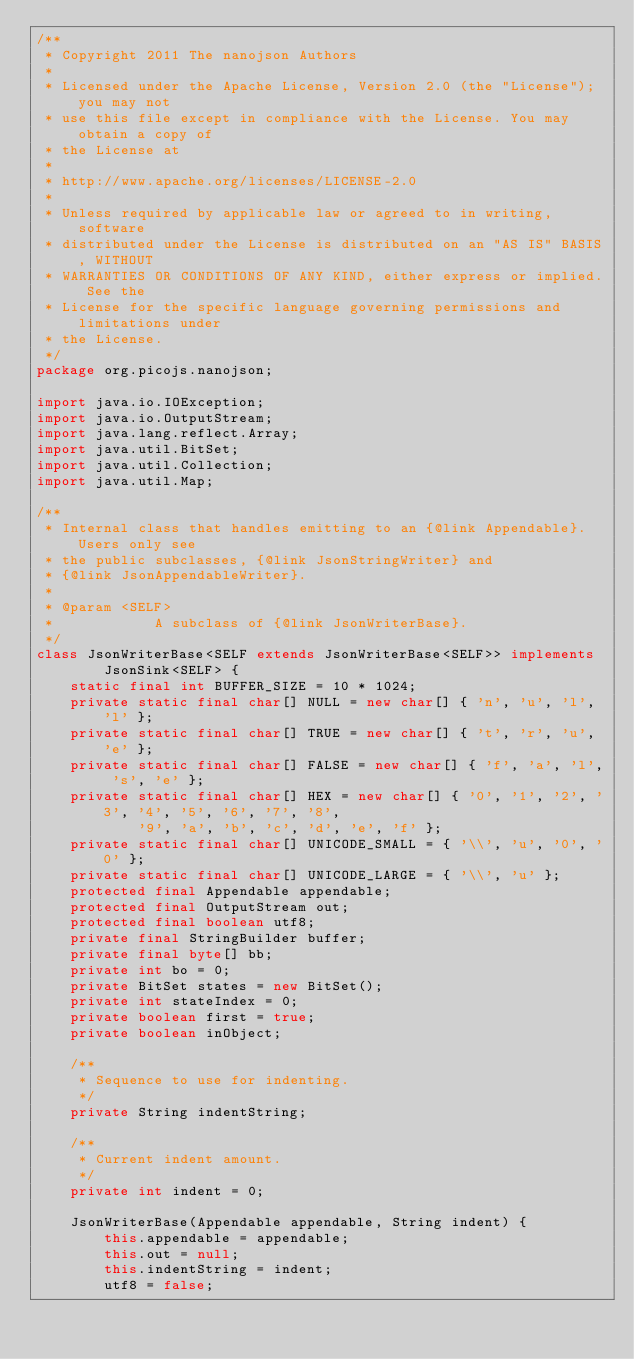<code> <loc_0><loc_0><loc_500><loc_500><_Java_>/**
 * Copyright 2011 The nanojson Authors
 *
 * Licensed under the Apache License, Version 2.0 (the "License"); you may not
 * use this file except in compliance with the License. You may obtain a copy of
 * the License at
 *
 * http://www.apache.org/licenses/LICENSE-2.0
 *
 * Unless required by applicable law or agreed to in writing, software
 * distributed under the License is distributed on an "AS IS" BASIS, WITHOUT
 * WARRANTIES OR CONDITIONS OF ANY KIND, either express or implied. See the
 * License for the specific language governing permissions and limitations under
 * the License.
 */
package org.picojs.nanojson;

import java.io.IOException;
import java.io.OutputStream;
import java.lang.reflect.Array;
import java.util.BitSet;
import java.util.Collection;
import java.util.Map;

/**
 * Internal class that handles emitting to an {@link Appendable}. Users only see
 * the public subclasses, {@link JsonStringWriter} and
 * {@link JsonAppendableWriter}.
 * 
 * @param <SELF>
 *            A subclass of {@link JsonWriterBase}.
 */
class JsonWriterBase<SELF extends JsonWriterBase<SELF>> implements
		JsonSink<SELF> {
	static final int BUFFER_SIZE = 10 * 1024;
	private static final char[] NULL = new char[] { 'n', 'u', 'l', 'l' };
	private static final char[] TRUE = new char[] { 't', 'r', 'u', 'e' };
	private static final char[] FALSE = new char[] { 'f', 'a', 'l', 's', 'e' };
	private static final char[] HEX = new char[] { '0', '1', '2', '3', '4', '5', '6', '7', '8',
			'9', 'a', 'b', 'c', 'd', 'e', 'f' };
	private static final char[] UNICODE_SMALL = { '\\', 'u', '0', '0' };
	private static final char[] UNICODE_LARGE = { '\\', 'u' };
	protected final Appendable appendable;
	protected final OutputStream out;
	protected final boolean utf8;
	private final StringBuilder buffer;
	private final byte[] bb;
	private int bo = 0;
	private BitSet states = new BitSet();
	private int stateIndex = 0;
	private boolean first = true;
	private boolean inObject;

	/**
	 * Sequence to use for indenting.
	 */
	private String indentString;

	/**
	 * Current indent amount.
	 */
	private int indent = 0;

	JsonWriterBase(Appendable appendable, String indent) {
		this.appendable = appendable;
		this.out = null;
		this.indentString = indent;
		utf8 = false;</code> 